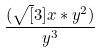Convert formula to latex. <formula><loc_0><loc_0><loc_500><loc_500>\frac { ( \sqrt { [ } 3 ] { x * y ^ { 2 } ) } } { y ^ { 3 } }</formula> 